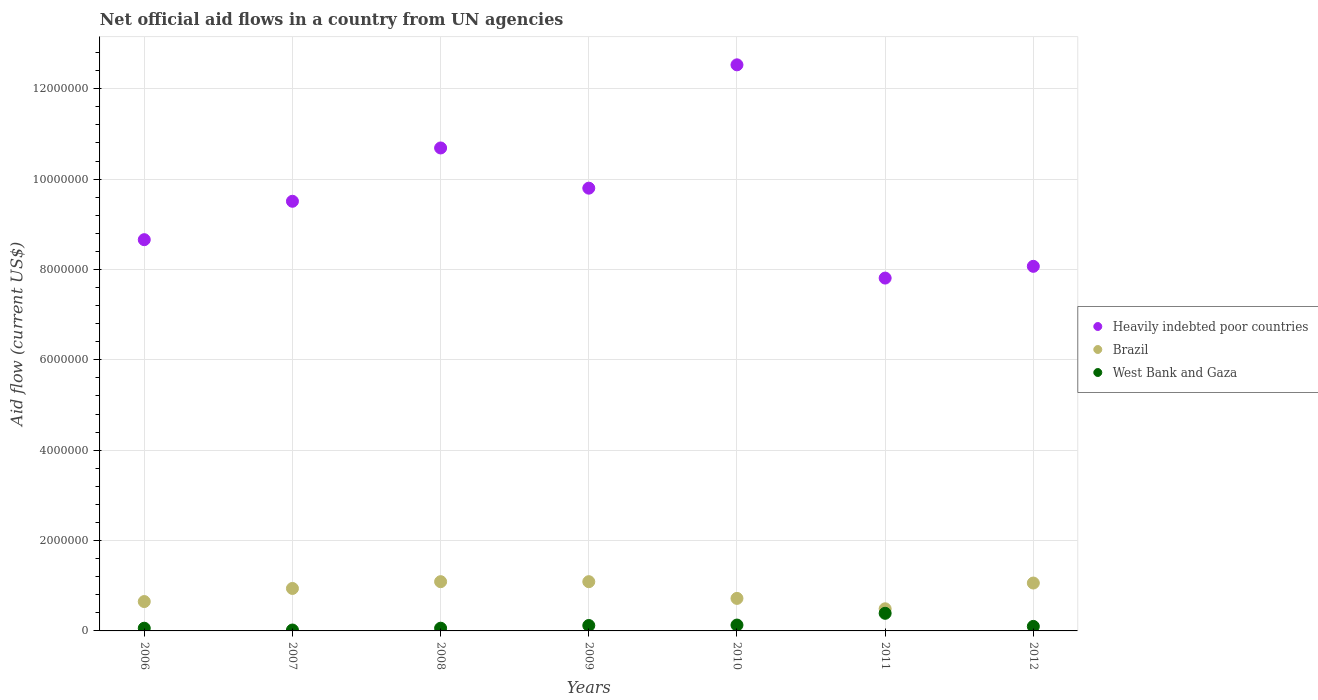Is the number of dotlines equal to the number of legend labels?
Offer a very short reply. Yes. What is the net official aid flow in Heavily indebted poor countries in 2009?
Offer a very short reply. 9.80e+06. Across all years, what is the maximum net official aid flow in Heavily indebted poor countries?
Offer a terse response. 1.25e+07. Across all years, what is the minimum net official aid flow in Brazil?
Offer a terse response. 4.90e+05. In which year was the net official aid flow in West Bank and Gaza maximum?
Offer a terse response. 2011. What is the total net official aid flow in West Bank and Gaza in the graph?
Offer a terse response. 8.80e+05. What is the difference between the net official aid flow in West Bank and Gaza in 2008 and that in 2011?
Your answer should be very brief. -3.30e+05. What is the difference between the net official aid flow in Brazil in 2009 and the net official aid flow in Heavily indebted poor countries in 2008?
Keep it short and to the point. -9.60e+06. What is the average net official aid flow in Brazil per year?
Give a very brief answer. 8.63e+05. In the year 2012, what is the difference between the net official aid flow in West Bank and Gaza and net official aid flow in Brazil?
Offer a very short reply. -9.60e+05. In how many years, is the net official aid flow in Brazil greater than 8400000 US$?
Ensure brevity in your answer.  0. What is the ratio of the net official aid flow in Brazil in 2008 to that in 2010?
Offer a terse response. 1.51. Is the net official aid flow in Heavily indebted poor countries in 2006 less than that in 2009?
Your response must be concise. Yes. Is the difference between the net official aid flow in West Bank and Gaza in 2009 and 2010 greater than the difference between the net official aid flow in Brazil in 2009 and 2010?
Your answer should be compact. No. What is the difference between the highest and the second highest net official aid flow in West Bank and Gaza?
Your response must be concise. 2.60e+05. What is the difference between the highest and the lowest net official aid flow in Heavily indebted poor countries?
Provide a succinct answer. 4.72e+06. Is the sum of the net official aid flow in West Bank and Gaza in 2008 and 2012 greater than the maximum net official aid flow in Brazil across all years?
Your response must be concise. No. Is it the case that in every year, the sum of the net official aid flow in Heavily indebted poor countries and net official aid flow in Brazil  is greater than the net official aid flow in West Bank and Gaza?
Your answer should be compact. Yes. Is the net official aid flow in West Bank and Gaza strictly greater than the net official aid flow in Heavily indebted poor countries over the years?
Provide a short and direct response. No. Does the graph contain any zero values?
Offer a very short reply. No. Does the graph contain grids?
Your answer should be very brief. Yes. Where does the legend appear in the graph?
Provide a short and direct response. Center right. What is the title of the graph?
Make the answer very short. Net official aid flows in a country from UN agencies. Does "Other small states" appear as one of the legend labels in the graph?
Keep it short and to the point. No. What is the label or title of the X-axis?
Ensure brevity in your answer.  Years. What is the label or title of the Y-axis?
Provide a short and direct response. Aid flow (current US$). What is the Aid flow (current US$) of Heavily indebted poor countries in 2006?
Offer a terse response. 8.66e+06. What is the Aid flow (current US$) of Brazil in 2006?
Offer a very short reply. 6.50e+05. What is the Aid flow (current US$) of Heavily indebted poor countries in 2007?
Make the answer very short. 9.51e+06. What is the Aid flow (current US$) in Brazil in 2007?
Give a very brief answer. 9.40e+05. What is the Aid flow (current US$) of Heavily indebted poor countries in 2008?
Your answer should be very brief. 1.07e+07. What is the Aid flow (current US$) of Brazil in 2008?
Your answer should be compact. 1.09e+06. What is the Aid flow (current US$) in Heavily indebted poor countries in 2009?
Ensure brevity in your answer.  9.80e+06. What is the Aid flow (current US$) in Brazil in 2009?
Keep it short and to the point. 1.09e+06. What is the Aid flow (current US$) of West Bank and Gaza in 2009?
Your answer should be very brief. 1.20e+05. What is the Aid flow (current US$) of Heavily indebted poor countries in 2010?
Offer a very short reply. 1.25e+07. What is the Aid flow (current US$) in Brazil in 2010?
Keep it short and to the point. 7.20e+05. What is the Aid flow (current US$) in West Bank and Gaza in 2010?
Offer a terse response. 1.30e+05. What is the Aid flow (current US$) of Heavily indebted poor countries in 2011?
Offer a very short reply. 7.81e+06. What is the Aid flow (current US$) of Brazil in 2011?
Provide a short and direct response. 4.90e+05. What is the Aid flow (current US$) of Heavily indebted poor countries in 2012?
Keep it short and to the point. 8.07e+06. What is the Aid flow (current US$) in Brazil in 2012?
Offer a terse response. 1.06e+06. What is the Aid flow (current US$) of West Bank and Gaza in 2012?
Offer a terse response. 1.00e+05. Across all years, what is the maximum Aid flow (current US$) in Heavily indebted poor countries?
Your answer should be compact. 1.25e+07. Across all years, what is the maximum Aid flow (current US$) in Brazil?
Keep it short and to the point. 1.09e+06. Across all years, what is the maximum Aid flow (current US$) in West Bank and Gaza?
Keep it short and to the point. 3.90e+05. Across all years, what is the minimum Aid flow (current US$) in Heavily indebted poor countries?
Give a very brief answer. 7.81e+06. Across all years, what is the minimum Aid flow (current US$) in Brazil?
Keep it short and to the point. 4.90e+05. What is the total Aid flow (current US$) in Heavily indebted poor countries in the graph?
Keep it short and to the point. 6.71e+07. What is the total Aid flow (current US$) in Brazil in the graph?
Your answer should be very brief. 6.04e+06. What is the total Aid flow (current US$) of West Bank and Gaza in the graph?
Give a very brief answer. 8.80e+05. What is the difference between the Aid flow (current US$) of Heavily indebted poor countries in 2006 and that in 2007?
Ensure brevity in your answer.  -8.50e+05. What is the difference between the Aid flow (current US$) in West Bank and Gaza in 2006 and that in 2007?
Offer a very short reply. 4.00e+04. What is the difference between the Aid flow (current US$) in Heavily indebted poor countries in 2006 and that in 2008?
Provide a succinct answer. -2.03e+06. What is the difference between the Aid flow (current US$) in Brazil in 2006 and that in 2008?
Provide a succinct answer. -4.40e+05. What is the difference between the Aid flow (current US$) in West Bank and Gaza in 2006 and that in 2008?
Keep it short and to the point. 0. What is the difference between the Aid flow (current US$) of Heavily indebted poor countries in 2006 and that in 2009?
Offer a terse response. -1.14e+06. What is the difference between the Aid flow (current US$) of Brazil in 2006 and that in 2009?
Give a very brief answer. -4.40e+05. What is the difference between the Aid flow (current US$) in West Bank and Gaza in 2006 and that in 2009?
Your response must be concise. -6.00e+04. What is the difference between the Aid flow (current US$) in Heavily indebted poor countries in 2006 and that in 2010?
Ensure brevity in your answer.  -3.87e+06. What is the difference between the Aid flow (current US$) of Brazil in 2006 and that in 2010?
Give a very brief answer. -7.00e+04. What is the difference between the Aid flow (current US$) of West Bank and Gaza in 2006 and that in 2010?
Provide a short and direct response. -7.00e+04. What is the difference between the Aid flow (current US$) of Heavily indebted poor countries in 2006 and that in 2011?
Keep it short and to the point. 8.50e+05. What is the difference between the Aid flow (current US$) in Brazil in 2006 and that in 2011?
Your answer should be compact. 1.60e+05. What is the difference between the Aid flow (current US$) in West Bank and Gaza in 2006 and that in 2011?
Offer a terse response. -3.30e+05. What is the difference between the Aid flow (current US$) of Heavily indebted poor countries in 2006 and that in 2012?
Your answer should be compact. 5.90e+05. What is the difference between the Aid flow (current US$) of Brazil in 2006 and that in 2012?
Your response must be concise. -4.10e+05. What is the difference between the Aid flow (current US$) in West Bank and Gaza in 2006 and that in 2012?
Provide a short and direct response. -4.00e+04. What is the difference between the Aid flow (current US$) in Heavily indebted poor countries in 2007 and that in 2008?
Offer a very short reply. -1.18e+06. What is the difference between the Aid flow (current US$) of West Bank and Gaza in 2007 and that in 2008?
Make the answer very short. -4.00e+04. What is the difference between the Aid flow (current US$) of Heavily indebted poor countries in 2007 and that in 2010?
Provide a succinct answer. -3.02e+06. What is the difference between the Aid flow (current US$) in Brazil in 2007 and that in 2010?
Offer a very short reply. 2.20e+05. What is the difference between the Aid flow (current US$) of West Bank and Gaza in 2007 and that in 2010?
Offer a terse response. -1.10e+05. What is the difference between the Aid flow (current US$) of Heavily indebted poor countries in 2007 and that in 2011?
Your answer should be compact. 1.70e+06. What is the difference between the Aid flow (current US$) in West Bank and Gaza in 2007 and that in 2011?
Your answer should be very brief. -3.70e+05. What is the difference between the Aid flow (current US$) of Heavily indebted poor countries in 2007 and that in 2012?
Provide a succinct answer. 1.44e+06. What is the difference between the Aid flow (current US$) of Brazil in 2007 and that in 2012?
Keep it short and to the point. -1.20e+05. What is the difference between the Aid flow (current US$) in Heavily indebted poor countries in 2008 and that in 2009?
Provide a succinct answer. 8.90e+05. What is the difference between the Aid flow (current US$) in West Bank and Gaza in 2008 and that in 2009?
Give a very brief answer. -6.00e+04. What is the difference between the Aid flow (current US$) of Heavily indebted poor countries in 2008 and that in 2010?
Keep it short and to the point. -1.84e+06. What is the difference between the Aid flow (current US$) of Brazil in 2008 and that in 2010?
Offer a terse response. 3.70e+05. What is the difference between the Aid flow (current US$) in Heavily indebted poor countries in 2008 and that in 2011?
Your response must be concise. 2.88e+06. What is the difference between the Aid flow (current US$) in Brazil in 2008 and that in 2011?
Offer a terse response. 6.00e+05. What is the difference between the Aid flow (current US$) in West Bank and Gaza in 2008 and that in 2011?
Make the answer very short. -3.30e+05. What is the difference between the Aid flow (current US$) of Heavily indebted poor countries in 2008 and that in 2012?
Offer a very short reply. 2.62e+06. What is the difference between the Aid flow (current US$) in Heavily indebted poor countries in 2009 and that in 2010?
Ensure brevity in your answer.  -2.73e+06. What is the difference between the Aid flow (current US$) of Brazil in 2009 and that in 2010?
Provide a short and direct response. 3.70e+05. What is the difference between the Aid flow (current US$) of West Bank and Gaza in 2009 and that in 2010?
Provide a succinct answer. -10000. What is the difference between the Aid flow (current US$) of Heavily indebted poor countries in 2009 and that in 2011?
Your response must be concise. 1.99e+06. What is the difference between the Aid flow (current US$) of Brazil in 2009 and that in 2011?
Ensure brevity in your answer.  6.00e+05. What is the difference between the Aid flow (current US$) of West Bank and Gaza in 2009 and that in 2011?
Ensure brevity in your answer.  -2.70e+05. What is the difference between the Aid flow (current US$) of Heavily indebted poor countries in 2009 and that in 2012?
Provide a short and direct response. 1.73e+06. What is the difference between the Aid flow (current US$) in Brazil in 2009 and that in 2012?
Your answer should be very brief. 3.00e+04. What is the difference between the Aid flow (current US$) in West Bank and Gaza in 2009 and that in 2012?
Your answer should be compact. 2.00e+04. What is the difference between the Aid flow (current US$) in Heavily indebted poor countries in 2010 and that in 2011?
Your answer should be very brief. 4.72e+06. What is the difference between the Aid flow (current US$) of Brazil in 2010 and that in 2011?
Provide a short and direct response. 2.30e+05. What is the difference between the Aid flow (current US$) in Heavily indebted poor countries in 2010 and that in 2012?
Your answer should be very brief. 4.46e+06. What is the difference between the Aid flow (current US$) in Brazil in 2010 and that in 2012?
Ensure brevity in your answer.  -3.40e+05. What is the difference between the Aid flow (current US$) in Heavily indebted poor countries in 2011 and that in 2012?
Your response must be concise. -2.60e+05. What is the difference between the Aid flow (current US$) in Brazil in 2011 and that in 2012?
Offer a very short reply. -5.70e+05. What is the difference between the Aid flow (current US$) in Heavily indebted poor countries in 2006 and the Aid flow (current US$) in Brazil in 2007?
Make the answer very short. 7.72e+06. What is the difference between the Aid flow (current US$) of Heavily indebted poor countries in 2006 and the Aid flow (current US$) of West Bank and Gaza in 2007?
Your answer should be compact. 8.64e+06. What is the difference between the Aid flow (current US$) in Brazil in 2006 and the Aid flow (current US$) in West Bank and Gaza in 2007?
Your response must be concise. 6.30e+05. What is the difference between the Aid flow (current US$) of Heavily indebted poor countries in 2006 and the Aid flow (current US$) of Brazil in 2008?
Offer a terse response. 7.57e+06. What is the difference between the Aid flow (current US$) of Heavily indebted poor countries in 2006 and the Aid flow (current US$) of West Bank and Gaza in 2008?
Provide a succinct answer. 8.60e+06. What is the difference between the Aid flow (current US$) in Brazil in 2006 and the Aid flow (current US$) in West Bank and Gaza in 2008?
Give a very brief answer. 5.90e+05. What is the difference between the Aid flow (current US$) in Heavily indebted poor countries in 2006 and the Aid flow (current US$) in Brazil in 2009?
Provide a short and direct response. 7.57e+06. What is the difference between the Aid flow (current US$) of Heavily indebted poor countries in 2006 and the Aid flow (current US$) of West Bank and Gaza in 2009?
Give a very brief answer. 8.54e+06. What is the difference between the Aid flow (current US$) of Brazil in 2006 and the Aid flow (current US$) of West Bank and Gaza in 2009?
Your response must be concise. 5.30e+05. What is the difference between the Aid flow (current US$) of Heavily indebted poor countries in 2006 and the Aid flow (current US$) of Brazil in 2010?
Keep it short and to the point. 7.94e+06. What is the difference between the Aid flow (current US$) in Heavily indebted poor countries in 2006 and the Aid flow (current US$) in West Bank and Gaza in 2010?
Your answer should be compact. 8.53e+06. What is the difference between the Aid flow (current US$) of Brazil in 2006 and the Aid flow (current US$) of West Bank and Gaza in 2010?
Your answer should be compact. 5.20e+05. What is the difference between the Aid flow (current US$) in Heavily indebted poor countries in 2006 and the Aid flow (current US$) in Brazil in 2011?
Provide a short and direct response. 8.17e+06. What is the difference between the Aid flow (current US$) of Heavily indebted poor countries in 2006 and the Aid flow (current US$) of West Bank and Gaza in 2011?
Give a very brief answer. 8.27e+06. What is the difference between the Aid flow (current US$) of Heavily indebted poor countries in 2006 and the Aid flow (current US$) of Brazil in 2012?
Your answer should be very brief. 7.60e+06. What is the difference between the Aid flow (current US$) in Heavily indebted poor countries in 2006 and the Aid flow (current US$) in West Bank and Gaza in 2012?
Offer a terse response. 8.56e+06. What is the difference between the Aid flow (current US$) of Brazil in 2006 and the Aid flow (current US$) of West Bank and Gaza in 2012?
Your response must be concise. 5.50e+05. What is the difference between the Aid flow (current US$) of Heavily indebted poor countries in 2007 and the Aid flow (current US$) of Brazil in 2008?
Your answer should be compact. 8.42e+06. What is the difference between the Aid flow (current US$) of Heavily indebted poor countries in 2007 and the Aid flow (current US$) of West Bank and Gaza in 2008?
Provide a short and direct response. 9.45e+06. What is the difference between the Aid flow (current US$) in Brazil in 2007 and the Aid flow (current US$) in West Bank and Gaza in 2008?
Ensure brevity in your answer.  8.80e+05. What is the difference between the Aid flow (current US$) in Heavily indebted poor countries in 2007 and the Aid flow (current US$) in Brazil in 2009?
Make the answer very short. 8.42e+06. What is the difference between the Aid flow (current US$) in Heavily indebted poor countries in 2007 and the Aid flow (current US$) in West Bank and Gaza in 2009?
Your response must be concise. 9.39e+06. What is the difference between the Aid flow (current US$) of Brazil in 2007 and the Aid flow (current US$) of West Bank and Gaza in 2009?
Keep it short and to the point. 8.20e+05. What is the difference between the Aid flow (current US$) in Heavily indebted poor countries in 2007 and the Aid flow (current US$) in Brazil in 2010?
Make the answer very short. 8.79e+06. What is the difference between the Aid flow (current US$) in Heavily indebted poor countries in 2007 and the Aid flow (current US$) in West Bank and Gaza in 2010?
Give a very brief answer. 9.38e+06. What is the difference between the Aid flow (current US$) in Brazil in 2007 and the Aid flow (current US$) in West Bank and Gaza in 2010?
Offer a very short reply. 8.10e+05. What is the difference between the Aid flow (current US$) of Heavily indebted poor countries in 2007 and the Aid flow (current US$) of Brazil in 2011?
Provide a short and direct response. 9.02e+06. What is the difference between the Aid flow (current US$) of Heavily indebted poor countries in 2007 and the Aid flow (current US$) of West Bank and Gaza in 2011?
Ensure brevity in your answer.  9.12e+06. What is the difference between the Aid flow (current US$) in Heavily indebted poor countries in 2007 and the Aid flow (current US$) in Brazil in 2012?
Offer a terse response. 8.45e+06. What is the difference between the Aid flow (current US$) of Heavily indebted poor countries in 2007 and the Aid flow (current US$) of West Bank and Gaza in 2012?
Your response must be concise. 9.41e+06. What is the difference between the Aid flow (current US$) in Brazil in 2007 and the Aid flow (current US$) in West Bank and Gaza in 2012?
Make the answer very short. 8.40e+05. What is the difference between the Aid flow (current US$) of Heavily indebted poor countries in 2008 and the Aid flow (current US$) of Brazil in 2009?
Your response must be concise. 9.60e+06. What is the difference between the Aid flow (current US$) of Heavily indebted poor countries in 2008 and the Aid flow (current US$) of West Bank and Gaza in 2009?
Ensure brevity in your answer.  1.06e+07. What is the difference between the Aid flow (current US$) in Brazil in 2008 and the Aid flow (current US$) in West Bank and Gaza in 2009?
Provide a short and direct response. 9.70e+05. What is the difference between the Aid flow (current US$) in Heavily indebted poor countries in 2008 and the Aid flow (current US$) in Brazil in 2010?
Make the answer very short. 9.97e+06. What is the difference between the Aid flow (current US$) of Heavily indebted poor countries in 2008 and the Aid flow (current US$) of West Bank and Gaza in 2010?
Make the answer very short. 1.06e+07. What is the difference between the Aid flow (current US$) in Brazil in 2008 and the Aid flow (current US$) in West Bank and Gaza in 2010?
Provide a short and direct response. 9.60e+05. What is the difference between the Aid flow (current US$) in Heavily indebted poor countries in 2008 and the Aid flow (current US$) in Brazil in 2011?
Ensure brevity in your answer.  1.02e+07. What is the difference between the Aid flow (current US$) of Heavily indebted poor countries in 2008 and the Aid flow (current US$) of West Bank and Gaza in 2011?
Keep it short and to the point. 1.03e+07. What is the difference between the Aid flow (current US$) of Brazil in 2008 and the Aid flow (current US$) of West Bank and Gaza in 2011?
Give a very brief answer. 7.00e+05. What is the difference between the Aid flow (current US$) in Heavily indebted poor countries in 2008 and the Aid flow (current US$) in Brazil in 2012?
Ensure brevity in your answer.  9.63e+06. What is the difference between the Aid flow (current US$) of Heavily indebted poor countries in 2008 and the Aid flow (current US$) of West Bank and Gaza in 2012?
Offer a very short reply. 1.06e+07. What is the difference between the Aid flow (current US$) in Brazil in 2008 and the Aid flow (current US$) in West Bank and Gaza in 2012?
Give a very brief answer. 9.90e+05. What is the difference between the Aid flow (current US$) in Heavily indebted poor countries in 2009 and the Aid flow (current US$) in Brazil in 2010?
Keep it short and to the point. 9.08e+06. What is the difference between the Aid flow (current US$) in Heavily indebted poor countries in 2009 and the Aid flow (current US$) in West Bank and Gaza in 2010?
Your answer should be compact. 9.67e+06. What is the difference between the Aid flow (current US$) in Brazil in 2009 and the Aid flow (current US$) in West Bank and Gaza in 2010?
Provide a succinct answer. 9.60e+05. What is the difference between the Aid flow (current US$) of Heavily indebted poor countries in 2009 and the Aid flow (current US$) of Brazil in 2011?
Provide a succinct answer. 9.31e+06. What is the difference between the Aid flow (current US$) of Heavily indebted poor countries in 2009 and the Aid flow (current US$) of West Bank and Gaza in 2011?
Your response must be concise. 9.41e+06. What is the difference between the Aid flow (current US$) of Brazil in 2009 and the Aid flow (current US$) of West Bank and Gaza in 2011?
Offer a terse response. 7.00e+05. What is the difference between the Aid flow (current US$) of Heavily indebted poor countries in 2009 and the Aid flow (current US$) of Brazil in 2012?
Your answer should be compact. 8.74e+06. What is the difference between the Aid flow (current US$) in Heavily indebted poor countries in 2009 and the Aid flow (current US$) in West Bank and Gaza in 2012?
Your answer should be compact. 9.70e+06. What is the difference between the Aid flow (current US$) in Brazil in 2009 and the Aid flow (current US$) in West Bank and Gaza in 2012?
Your answer should be compact. 9.90e+05. What is the difference between the Aid flow (current US$) in Heavily indebted poor countries in 2010 and the Aid flow (current US$) in Brazil in 2011?
Your response must be concise. 1.20e+07. What is the difference between the Aid flow (current US$) of Heavily indebted poor countries in 2010 and the Aid flow (current US$) of West Bank and Gaza in 2011?
Offer a terse response. 1.21e+07. What is the difference between the Aid flow (current US$) in Brazil in 2010 and the Aid flow (current US$) in West Bank and Gaza in 2011?
Give a very brief answer. 3.30e+05. What is the difference between the Aid flow (current US$) of Heavily indebted poor countries in 2010 and the Aid flow (current US$) of Brazil in 2012?
Keep it short and to the point. 1.15e+07. What is the difference between the Aid flow (current US$) of Heavily indebted poor countries in 2010 and the Aid flow (current US$) of West Bank and Gaza in 2012?
Offer a very short reply. 1.24e+07. What is the difference between the Aid flow (current US$) of Brazil in 2010 and the Aid flow (current US$) of West Bank and Gaza in 2012?
Your answer should be very brief. 6.20e+05. What is the difference between the Aid flow (current US$) of Heavily indebted poor countries in 2011 and the Aid flow (current US$) of Brazil in 2012?
Ensure brevity in your answer.  6.75e+06. What is the difference between the Aid flow (current US$) in Heavily indebted poor countries in 2011 and the Aid flow (current US$) in West Bank and Gaza in 2012?
Ensure brevity in your answer.  7.71e+06. What is the difference between the Aid flow (current US$) of Brazil in 2011 and the Aid flow (current US$) of West Bank and Gaza in 2012?
Keep it short and to the point. 3.90e+05. What is the average Aid flow (current US$) in Heavily indebted poor countries per year?
Your response must be concise. 9.58e+06. What is the average Aid flow (current US$) in Brazil per year?
Your answer should be compact. 8.63e+05. What is the average Aid flow (current US$) in West Bank and Gaza per year?
Provide a short and direct response. 1.26e+05. In the year 2006, what is the difference between the Aid flow (current US$) in Heavily indebted poor countries and Aid flow (current US$) in Brazil?
Provide a succinct answer. 8.01e+06. In the year 2006, what is the difference between the Aid flow (current US$) of Heavily indebted poor countries and Aid flow (current US$) of West Bank and Gaza?
Offer a very short reply. 8.60e+06. In the year 2006, what is the difference between the Aid flow (current US$) of Brazil and Aid flow (current US$) of West Bank and Gaza?
Ensure brevity in your answer.  5.90e+05. In the year 2007, what is the difference between the Aid flow (current US$) of Heavily indebted poor countries and Aid flow (current US$) of Brazil?
Keep it short and to the point. 8.57e+06. In the year 2007, what is the difference between the Aid flow (current US$) in Heavily indebted poor countries and Aid flow (current US$) in West Bank and Gaza?
Ensure brevity in your answer.  9.49e+06. In the year 2007, what is the difference between the Aid flow (current US$) of Brazil and Aid flow (current US$) of West Bank and Gaza?
Offer a terse response. 9.20e+05. In the year 2008, what is the difference between the Aid flow (current US$) in Heavily indebted poor countries and Aid flow (current US$) in Brazil?
Make the answer very short. 9.60e+06. In the year 2008, what is the difference between the Aid flow (current US$) in Heavily indebted poor countries and Aid flow (current US$) in West Bank and Gaza?
Provide a succinct answer. 1.06e+07. In the year 2008, what is the difference between the Aid flow (current US$) in Brazil and Aid flow (current US$) in West Bank and Gaza?
Offer a terse response. 1.03e+06. In the year 2009, what is the difference between the Aid flow (current US$) of Heavily indebted poor countries and Aid flow (current US$) of Brazil?
Provide a short and direct response. 8.71e+06. In the year 2009, what is the difference between the Aid flow (current US$) in Heavily indebted poor countries and Aid flow (current US$) in West Bank and Gaza?
Provide a succinct answer. 9.68e+06. In the year 2009, what is the difference between the Aid flow (current US$) in Brazil and Aid flow (current US$) in West Bank and Gaza?
Ensure brevity in your answer.  9.70e+05. In the year 2010, what is the difference between the Aid flow (current US$) of Heavily indebted poor countries and Aid flow (current US$) of Brazil?
Make the answer very short. 1.18e+07. In the year 2010, what is the difference between the Aid flow (current US$) in Heavily indebted poor countries and Aid flow (current US$) in West Bank and Gaza?
Keep it short and to the point. 1.24e+07. In the year 2010, what is the difference between the Aid flow (current US$) in Brazil and Aid flow (current US$) in West Bank and Gaza?
Offer a terse response. 5.90e+05. In the year 2011, what is the difference between the Aid flow (current US$) in Heavily indebted poor countries and Aid flow (current US$) in Brazil?
Offer a very short reply. 7.32e+06. In the year 2011, what is the difference between the Aid flow (current US$) in Heavily indebted poor countries and Aid flow (current US$) in West Bank and Gaza?
Give a very brief answer. 7.42e+06. In the year 2011, what is the difference between the Aid flow (current US$) of Brazil and Aid flow (current US$) of West Bank and Gaza?
Offer a very short reply. 1.00e+05. In the year 2012, what is the difference between the Aid flow (current US$) of Heavily indebted poor countries and Aid flow (current US$) of Brazil?
Provide a succinct answer. 7.01e+06. In the year 2012, what is the difference between the Aid flow (current US$) of Heavily indebted poor countries and Aid flow (current US$) of West Bank and Gaza?
Provide a succinct answer. 7.97e+06. In the year 2012, what is the difference between the Aid flow (current US$) in Brazil and Aid flow (current US$) in West Bank and Gaza?
Your answer should be compact. 9.60e+05. What is the ratio of the Aid flow (current US$) of Heavily indebted poor countries in 2006 to that in 2007?
Offer a very short reply. 0.91. What is the ratio of the Aid flow (current US$) in Brazil in 2006 to that in 2007?
Keep it short and to the point. 0.69. What is the ratio of the Aid flow (current US$) in West Bank and Gaza in 2006 to that in 2007?
Your answer should be compact. 3. What is the ratio of the Aid flow (current US$) in Heavily indebted poor countries in 2006 to that in 2008?
Offer a terse response. 0.81. What is the ratio of the Aid flow (current US$) of Brazil in 2006 to that in 2008?
Offer a very short reply. 0.6. What is the ratio of the Aid flow (current US$) of West Bank and Gaza in 2006 to that in 2008?
Make the answer very short. 1. What is the ratio of the Aid flow (current US$) in Heavily indebted poor countries in 2006 to that in 2009?
Keep it short and to the point. 0.88. What is the ratio of the Aid flow (current US$) of Brazil in 2006 to that in 2009?
Keep it short and to the point. 0.6. What is the ratio of the Aid flow (current US$) of Heavily indebted poor countries in 2006 to that in 2010?
Give a very brief answer. 0.69. What is the ratio of the Aid flow (current US$) in Brazil in 2006 to that in 2010?
Your answer should be very brief. 0.9. What is the ratio of the Aid flow (current US$) of West Bank and Gaza in 2006 to that in 2010?
Offer a very short reply. 0.46. What is the ratio of the Aid flow (current US$) in Heavily indebted poor countries in 2006 to that in 2011?
Provide a short and direct response. 1.11. What is the ratio of the Aid flow (current US$) of Brazil in 2006 to that in 2011?
Give a very brief answer. 1.33. What is the ratio of the Aid flow (current US$) of West Bank and Gaza in 2006 to that in 2011?
Keep it short and to the point. 0.15. What is the ratio of the Aid flow (current US$) of Heavily indebted poor countries in 2006 to that in 2012?
Keep it short and to the point. 1.07. What is the ratio of the Aid flow (current US$) in Brazil in 2006 to that in 2012?
Your answer should be very brief. 0.61. What is the ratio of the Aid flow (current US$) in West Bank and Gaza in 2006 to that in 2012?
Provide a short and direct response. 0.6. What is the ratio of the Aid flow (current US$) in Heavily indebted poor countries in 2007 to that in 2008?
Keep it short and to the point. 0.89. What is the ratio of the Aid flow (current US$) of Brazil in 2007 to that in 2008?
Your response must be concise. 0.86. What is the ratio of the Aid flow (current US$) in Heavily indebted poor countries in 2007 to that in 2009?
Provide a short and direct response. 0.97. What is the ratio of the Aid flow (current US$) in Brazil in 2007 to that in 2009?
Provide a succinct answer. 0.86. What is the ratio of the Aid flow (current US$) of West Bank and Gaza in 2007 to that in 2009?
Ensure brevity in your answer.  0.17. What is the ratio of the Aid flow (current US$) in Heavily indebted poor countries in 2007 to that in 2010?
Ensure brevity in your answer.  0.76. What is the ratio of the Aid flow (current US$) of Brazil in 2007 to that in 2010?
Your response must be concise. 1.31. What is the ratio of the Aid flow (current US$) in West Bank and Gaza in 2007 to that in 2010?
Keep it short and to the point. 0.15. What is the ratio of the Aid flow (current US$) of Heavily indebted poor countries in 2007 to that in 2011?
Your answer should be very brief. 1.22. What is the ratio of the Aid flow (current US$) in Brazil in 2007 to that in 2011?
Your answer should be very brief. 1.92. What is the ratio of the Aid flow (current US$) in West Bank and Gaza in 2007 to that in 2011?
Give a very brief answer. 0.05. What is the ratio of the Aid flow (current US$) of Heavily indebted poor countries in 2007 to that in 2012?
Provide a short and direct response. 1.18. What is the ratio of the Aid flow (current US$) of Brazil in 2007 to that in 2012?
Offer a very short reply. 0.89. What is the ratio of the Aid flow (current US$) in West Bank and Gaza in 2007 to that in 2012?
Your answer should be compact. 0.2. What is the ratio of the Aid flow (current US$) of Heavily indebted poor countries in 2008 to that in 2009?
Your answer should be very brief. 1.09. What is the ratio of the Aid flow (current US$) in Heavily indebted poor countries in 2008 to that in 2010?
Give a very brief answer. 0.85. What is the ratio of the Aid flow (current US$) in Brazil in 2008 to that in 2010?
Provide a short and direct response. 1.51. What is the ratio of the Aid flow (current US$) in West Bank and Gaza in 2008 to that in 2010?
Provide a short and direct response. 0.46. What is the ratio of the Aid flow (current US$) in Heavily indebted poor countries in 2008 to that in 2011?
Offer a terse response. 1.37. What is the ratio of the Aid flow (current US$) in Brazil in 2008 to that in 2011?
Your answer should be compact. 2.22. What is the ratio of the Aid flow (current US$) of West Bank and Gaza in 2008 to that in 2011?
Offer a terse response. 0.15. What is the ratio of the Aid flow (current US$) of Heavily indebted poor countries in 2008 to that in 2012?
Offer a very short reply. 1.32. What is the ratio of the Aid flow (current US$) in Brazil in 2008 to that in 2012?
Provide a short and direct response. 1.03. What is the ratio of the Aid flow (current US$) of West Bank and Gaza in 2008 to that in 2012?
Your answer should be very brief. 0.6. What is the ratio of the Aid flow (current US$) in Heavily indebted poor countries in 2009 to that in 2010?
Your answer should be compact. 0.78. What is the ratio of the Aid flow (current US$) of Brazil in 2009 to that in 2010?
Offer a very short reply. 1.51. What is the ratio of the Aid flow (current US$) in West Bank and Gaza in 2009 to that in 2010?
Your response must be concise. 0.92. What is the ratio of the Aid flow (current US$) in Heavily indebted poor countries in 2009 to that in 2011?
Offer a terse response. 1.25. What is the ratio of the Aid flow (current US$) in Brazil in 2009 to that in 2011?
Your answer should be compact. 2.22. What is the ratio of the Aid flow (current US$) of West Bank and Gaza in 2009 to that in 2011?
Give a very brief answer. 0.31. What is the ratio of the Aid flow (current US$) in Heavily indebted poor countries in 2009 to that in 2012?
Keep it short and to the point. 1.21. What is the ratio of the Aid flow (current US$) of Brazil in 2009 to that in 2012?
Your answer should be compact. 1.03. What is the ratio of the Aid flow (current US$) in West Bank and Gaza in 2009 to that in 2012?
Your response must be concise. 1.2. What is the ratio of the Aid flow (current US$) in Heavily indebted poor countries in 2010 to that in 2011?
Ensure brevity in your answer.  1.6. What is the ratio of the Aid flow (current US$) in Brazil in 2010 to that in 2011?
Give a very brief answer. 1.47. What is the ratio of the Aid flow (current US$) of Heavily indebted poor countries in 2010 to that in 2012?
Ensure brevity in your answer.  1.55. What is the ratio of the Aid flow (current US$) in Brazil in 2010 to that in 2012?
Offer a very short reply. 0.68. What is the ratio of the Aid flow (current US$) in Heavily indebted poor countries in 2011 to that in 2012?
Offer a very short reply. 0.97. What is the ratio of the Aid flow (current US$) in Brazil in 2011 to that in 2012?
Give a very brief answer. 0.46. What is the difference between the highest and the second highest Aid flow (current US$) in Heavily indebted poor countries?
Your response must be concise. 1.84e+06. What is the difference between the highest and the second highest Aid flow (current US$) in Brazil?
Your response must be concise. 0. What is the difference between the highest and the lowest Aid flow (current US$) of Heavily indebted poor countries?
Your answer should be very brief. 4.72e+06. What is the difference between the highest and the lowest Aid flow (current US$) in Brazil?
Provide a succinct answer. 6.00e+05. 